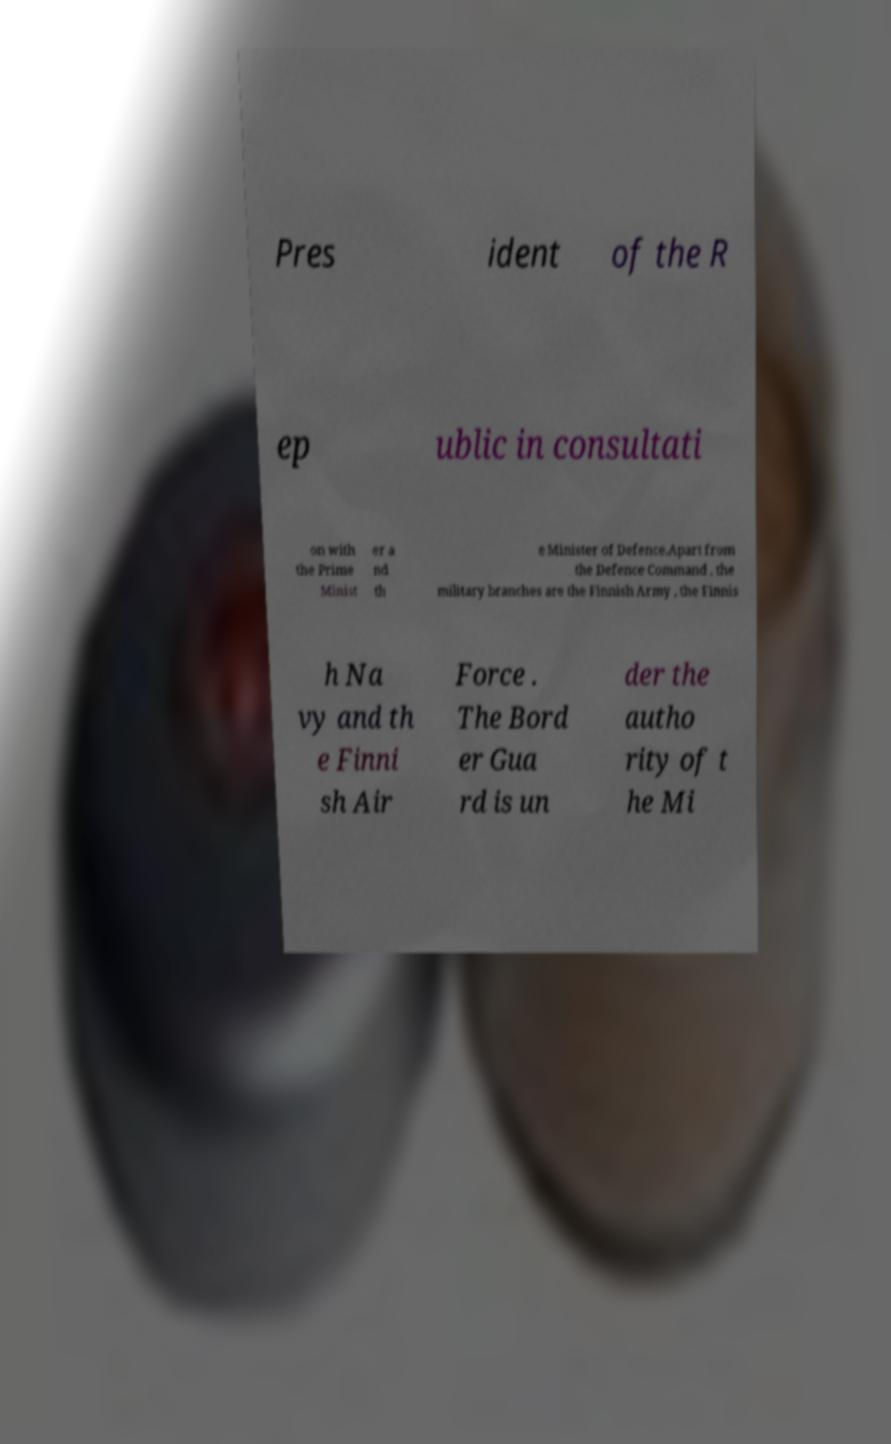Can you accurately transcribe the text from the provided image for me? Pres ident of the R ep ublic in consultati on with the Prime Minist er a nd th e Minister of Defence.Apart from the Defence Command , the military branches are the Finnish Army , the Finnis h Na vy and th e Finni sh Air Force . The Bord er Gua rd is un der the autho rity of t he Mi 